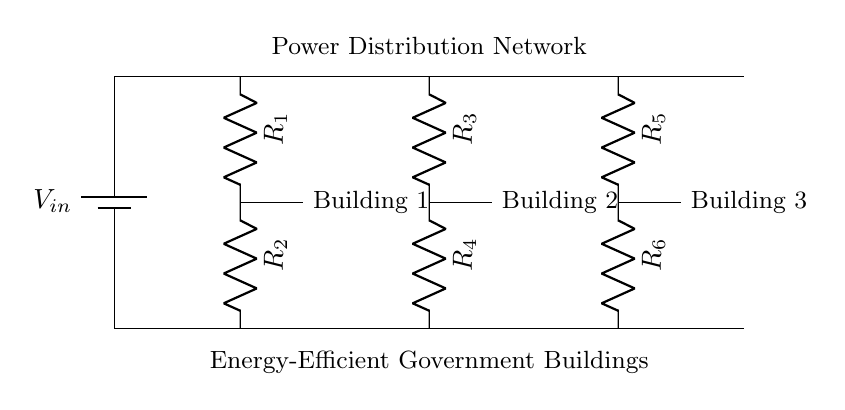What is the input voltage in the circuit? The input voltage is denoted as V_in in the circuit diagram, which typically refers to the voltage supplied by the battery.
Answer: V_in How many buildings are connected to the power distribution network? There are three buildings depicted in the circuit, each connected via resistors.
Answer: 3 What is the role of resistors in this circuit? Resistors in this voltage divider circuit serve to lower the voltage across each building, managing the distribution of power efficiently.
Answer: Lower voltage What type of circuit is shown in the diagram? The circuit is a voltage divider, which is specifically designed to create lower voltages from a higher input voltage through resistors.
Answer: Voltage divider How is the distribution of voltage achieved in this circuit? Voltage distribution is achieved through the use of series resistors, where the voltage drop across each resistor is proportional to its resistance.
Answer: Series resistors What is the connection layout of this power distribution network? The connection layout is a series configuration where each building's resistors connect in series with the input voltage, forming a path for power flow.
Answer: Series configuration What happens to the voltage across each building in this network? The voltage across each building decreases in a predictable manner based on the resistance values, following the voltage divider rule.
Answer: Decreases 